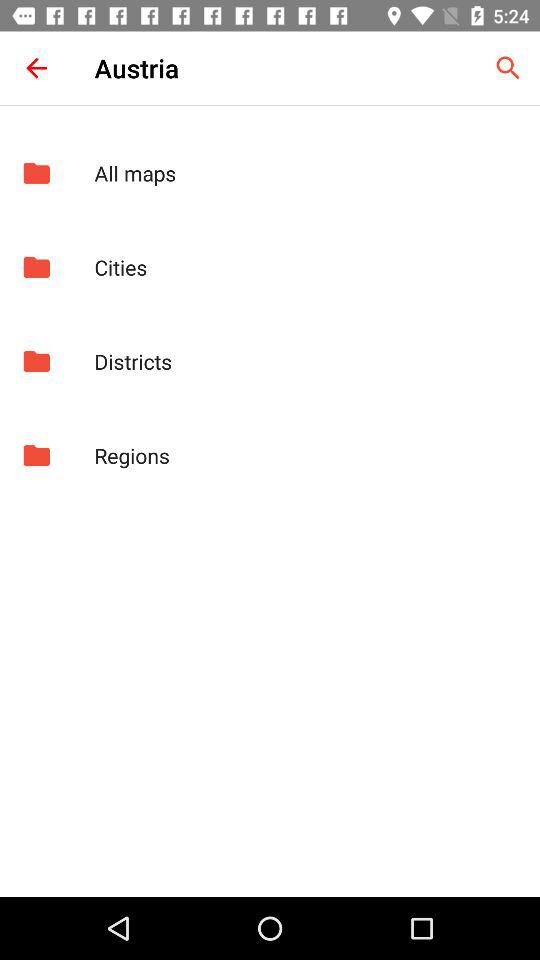What is the country name? The country name is Austria. 